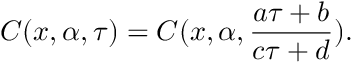<formula> <loc_0><loc_0><loc_500><loc_500>C ( x , \alpha , \tau ) = C ( x , \alpha , \frac { a \tau + b } { c \tau + d } ) .</formula> 